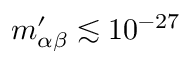Convert formula to latex. <formula><loc_0><loc_0><loc_500><loc_500>m _ { \alpha \beta } ^ { \prime } \lesssim 1 0 ^ { - 2 7 }</formula> 